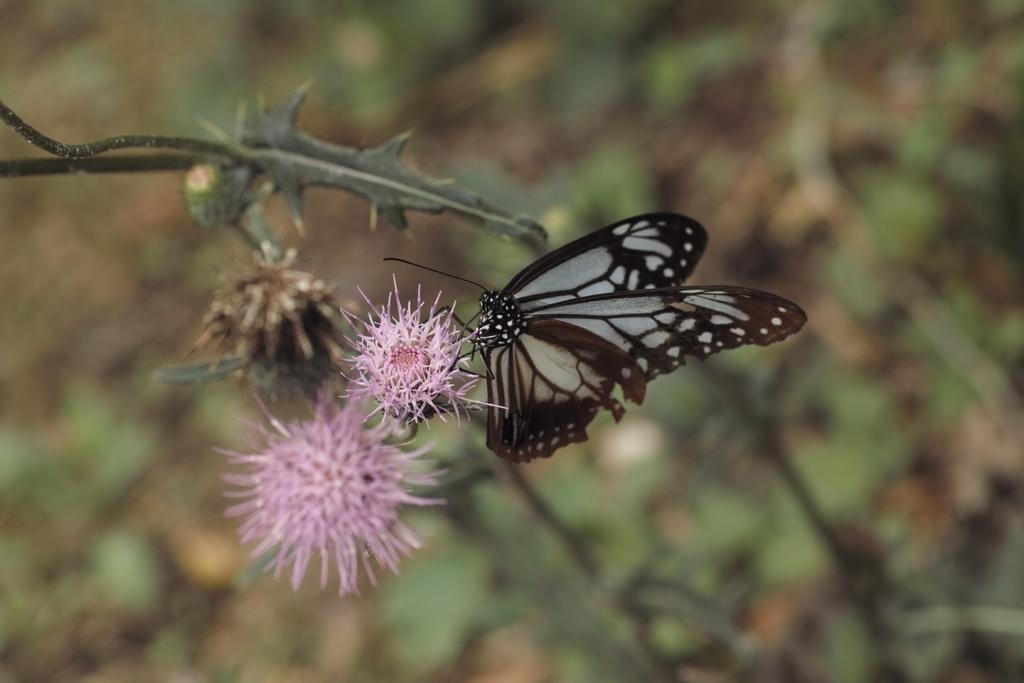What is the main subject of the image? There is a butterfly in the image. Where is the butterfly located in the image? The butterfly is on a flower. What type of cake is being served at the event in the image? There is no event or cake present in the image; it features a butterfly on a flower. What kind of suit is the person wearing in the image? There is no person or suit present in the image; it features a butterfly on a flower. 